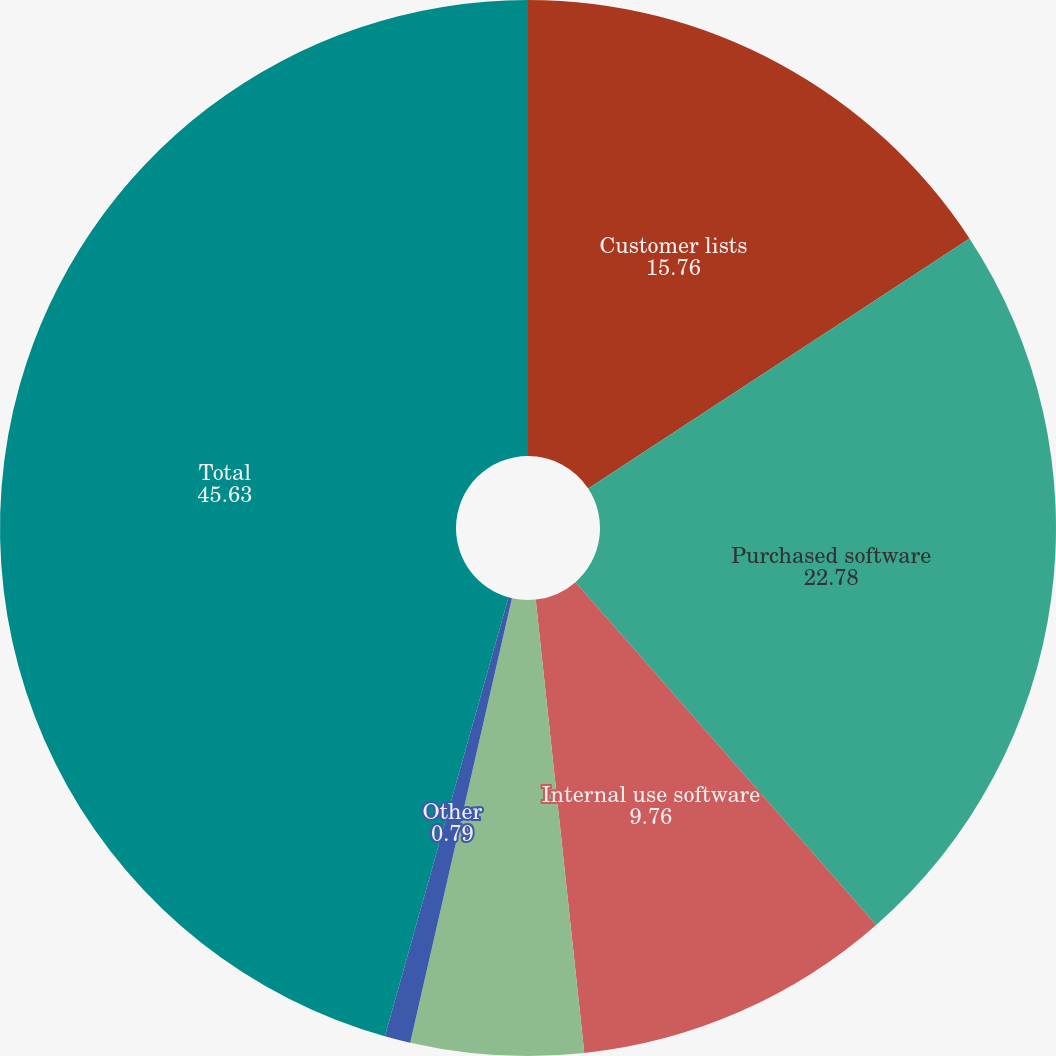<chart> <loc_0><loc_0><loc_500><loc_500><pie_chart><fcel>Customer lists<fcel>Purchased software<fcel>Internal use software<fcel>Trade names<fcel>Other<fcel>Total<nl><fcel>15.76%<fcel>22.78%<fcel>9.76%<fcel>5.28%<fcel>0.79%<fcel>45.63%<nl></chart> 